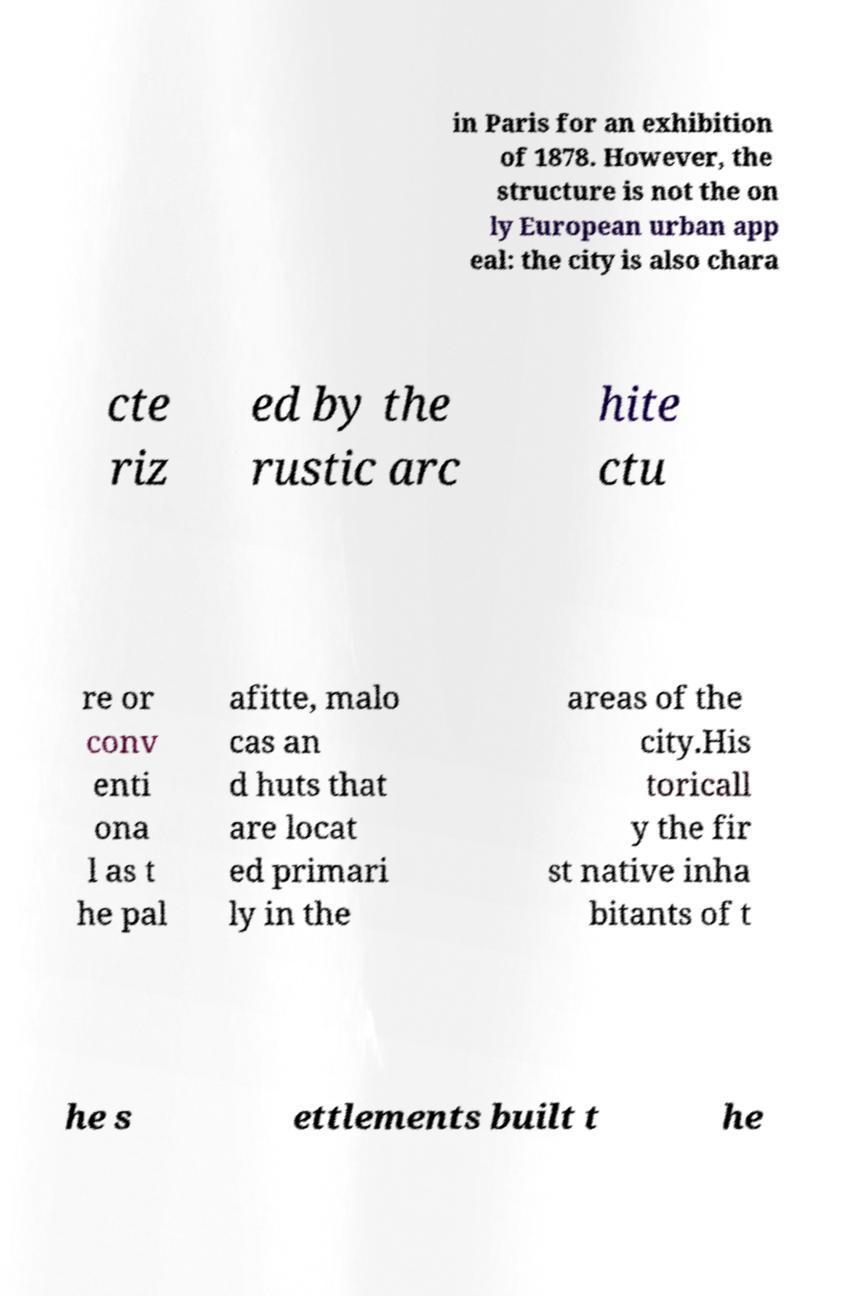What messages or text are displayed in this image? I need them in a readable, typed format. in Paris for an exhibition of 1878. However, the structure is not the on ly European urban app eal: the city is also chara cte riz ed by the rustic arc hite ctu re or conv enti ona l as t he pal afitte, malo cas an d huts that are locat ed primari ly in the areas of the city.His toricall y the fir st native inha bitants of t he s ettlements built t he 